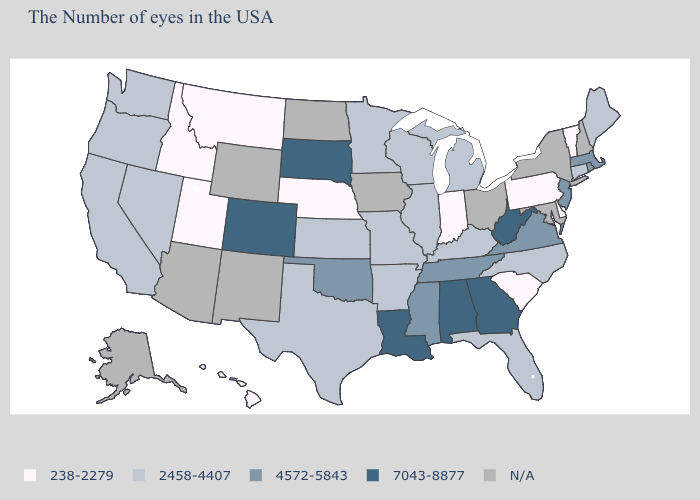What is the lowest value in the South?
Be succinct. 238-2279. What is the lowest value in the South?
Answer briefly. 238-2279. Name the states that have a value in the range 2458-4407?
Quick response, please. Maine, Connecticut, North Carolina, Florida, Michigan, Kentucky, Wisconsin, Illinois, Missouri, Arkansas, Minnesota, Kansas, Texas, Nevada, California, Washington, Oregon. What is the value of Maryland?
Give a very brief answer. N/A. What is the highest value in the USA?
Answer briefly. 7043-8877. Name the states that have a value in the range 2458-4407?
Quick response, please. Maine, Connecticut, North Carolina, Florida, Michigan, Kentucky, Wisconsin, Illinois, Missouri, Arkansas, Minnesota, Kansas, Texas, Nevada, California, Washington, Oregon. Name the states that have a value in the range 7043-8877?
Give a very brief answer. West Virginia, Georgia, Alabama, Louisiana, South Dakota, Colorado. Name the states that have a value in the range 2458-4407?
Be succinct. Maine, Connecticut, North Carolina, Florida, Michigan, Kentucky, Wisconsin, Illinois, Missouri, Arkansas, Minnesota, Kansas, Texas, Nevada, California, Washington, Oregon. Name the states that have a value in the range 4572-5843?
Answer briefly. Massachusetts, Rhode Island, New Jersey, Virginia, Tennessee, Mississippi, Oklahoma. Does Nebraska have the lowest value in the USA?
Give a very brief answer. Yes. Does Pennsylvania have the lowest value in the Northeast?
Write a very short answer. Yes. Name the states that have a value in the range N/A?
Be succinct. New Hampshire, New York, Maryland, Ohio, Iowa, North Dakota, Wyoming, New Mexico, Arizona, Alaska. Which states have the lowest value in the Northeast?
Concise answer only. Vermont, Pennsylvania. Name the states that have a value in the range N/A?
Give a very brief answer. New Hampshire, New York, Maryland, Ohio, Iowa, North Dakota, Wyoming, New Mexico, Arizona, Alaska. What is the value of California?
Concise answer only. 2458-4407. 